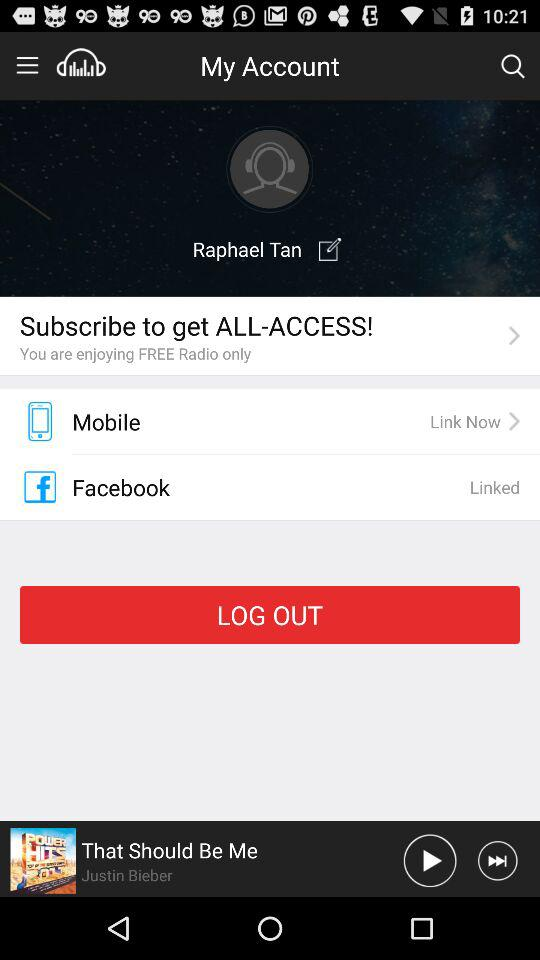What is the user's email address?
When the provided information is insufficient, respond with <no answer>. <no answer> 